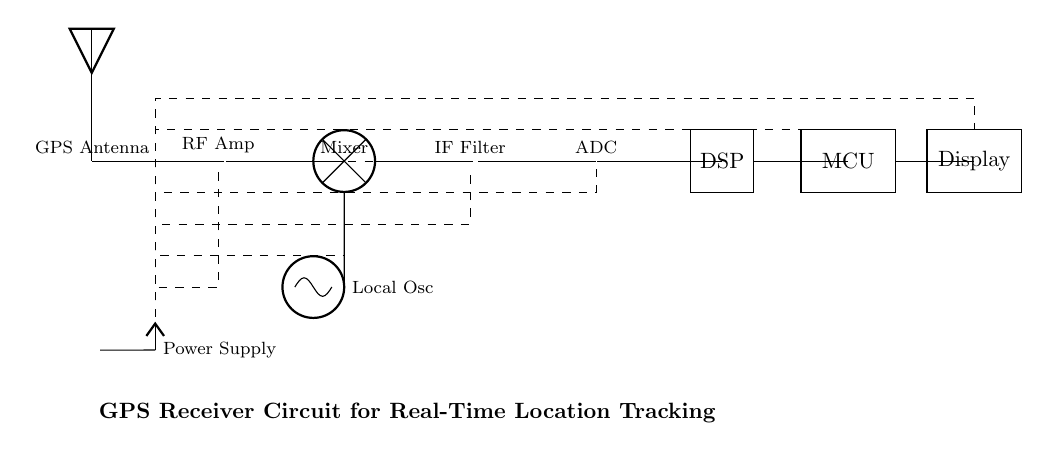What component receives GPS signals? The GPS antenna is the component in the circuit diagram that is designed to receive signals from GPS satellites. It is the first element in the diagram, indicating its role as the receiver for location information.
Answer: GPS Antenna What follows the RF amplifier in the circuit? After the RF amplifier, the next component in the signal chain is the mixer. This connection is crucial because the mixer combines the amplified signals with a local oscillator signal for further processing.
Answer: Mixer What type of filter is used in this circuit? The circuit incorporates a bandpass filter, which selectively allows signals of specific frequencies to pass while blocking others. This is essential in isolating the intermediate frequency signals after mixing.
Answer: IF Filter How many processing stages are present in the circuit? There are four main processing stages: the ADC, DSP, MCU, and Display. Each stage serves a specific function, from converting the analog signal into digital (ADC) to displaying the processed location information.
Answer: Four What is the power supply component in the circuit? The circuit uses a battery as the power supply component, providing the necessary voltage for operation. The battery is clearly labeled and connects to multiple components to ensure functional continuity.
Answer: Battery What is the role of the DSP in the system? The Digital Signal Processor (DSP) processes the digital signals received from the ADC, performing necessary calculations and conversions to determine location data, which will then be sent to the microcontroller.
Answer: Signal Processing 